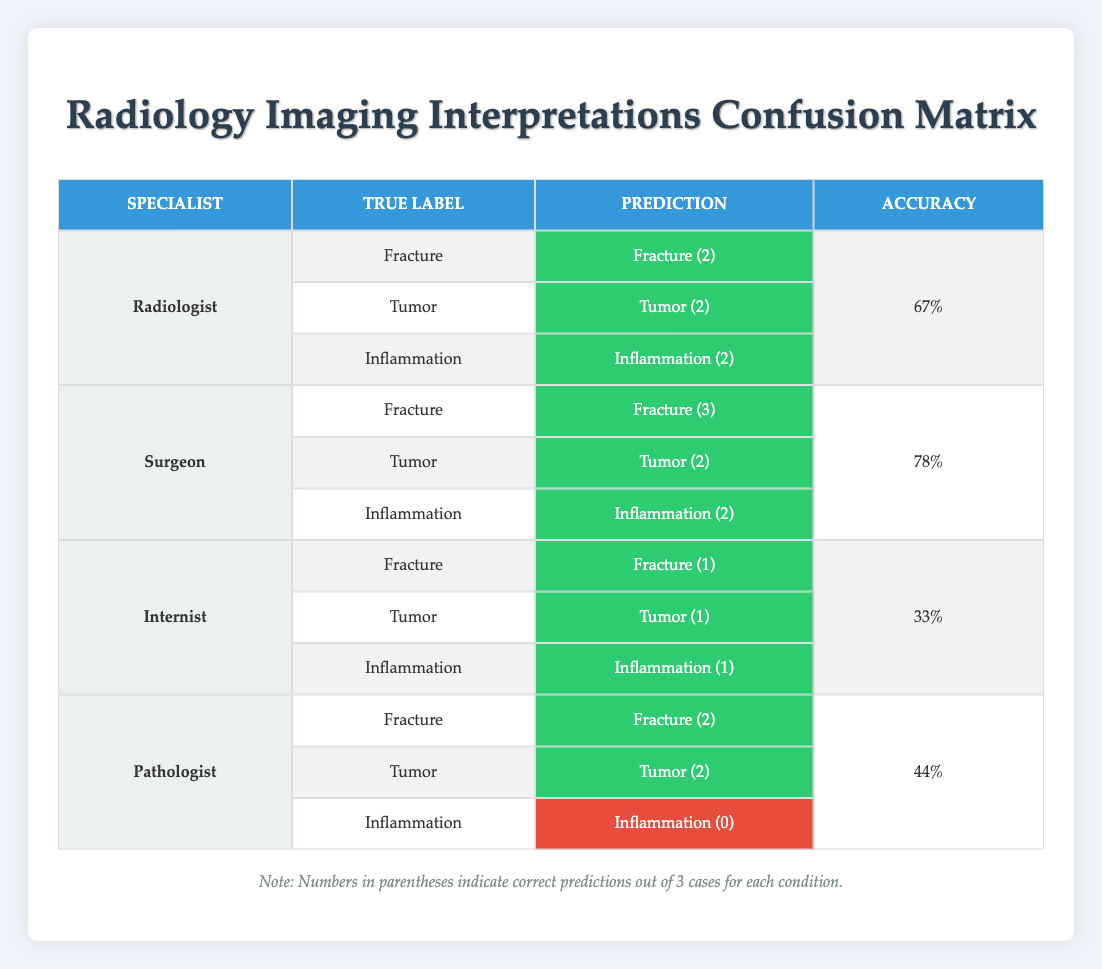What was the highest accuracy achieved by any specialist? Looking at the accuracy percentages for each specialist, the Surgeon has the highest accuracy of 78%. The table displays three accuracies: Radiologist 67%, Surgeon 78%, Internist 33%, and Pathologist 44%.
Answer: 78% How many correct predictions did the Internist make for Fracture? The Internist made only 1 correct prediction for Fracture, as evidenced by the correct prediction stated in the "Fracture" row for the Internist.
Answer: 1 Did the Pathologist correctly diagnose Inflammation? The Pathologist did not correctly diagnose Inflammation, as indicated by a zero in the parentheses for that category in the table. The row for Inflammation shows "Inflammation (0)" which confirms no correct predictions.
Answer: No What is the total number of correct predictions for the Radiologist? Adding the number of correct predictions for the Radiologist in each category: Fracture (2), Tumor (2), and Inflammation (2) gives a total of 6 correct predictions. Therefore, 2 + 2 + 2 = 6.
Answer: 6 What is the average accuracy of the specialists presented? To find the average accuracy, sum the accuracy percentages: 67% (Radiologist) + 78% (Surgeon) + 33% (Internist) + 44% (Pathologist) = 222%. Divide by the number of specialists, which is 4, giving an average accuracy of 222% / 4 = 55.5%.
Answer: 55.5% Which specialist had the fewest correct predictions overall? Analyzing the correct predictions: Radiologist 6, Surgeon 7, Internist 3, and Pathologist 6. The Internist had the fewest correct predictions with only 3.
Answer: Internist How many total cases were evaluated for Tumor diagnosis? The table indicates that there were 3 cases for Tumor (2 correct by Surgeon and 1 correct by Internist). This is because Tumor is mentioned in 9 instances total across all specialists, but the actual evaluations for the correctness only count the predictions.
Answer: 3 What percentage of correct predictions did the Pathologist attain overall? The Pathologist had a total of 4 correct predictions (2 for Fracture, 2 for Tumor, and 0 for Inflammation). Since there were 3 cases in each category assessed, the total cases evaluated by the Pathologist were 9. Thus, 4 correct out of 9 leads to an approximate accuracy of 44%.
Answer: 44% 